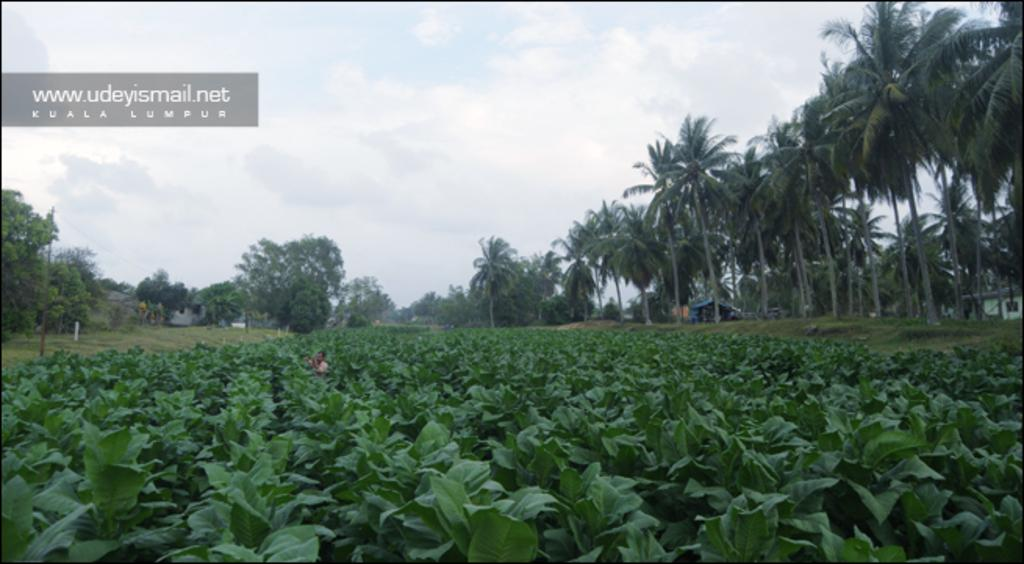What is the main subject of the image? There is a person standing in the image. Where is the person standing? The person is standing in the middle of a crop. What can be seen in the background of the image? There are trees and houses in the background of the image. How many dolls are sitting on the cows in the image? There are no dolls or cows present in the image. 